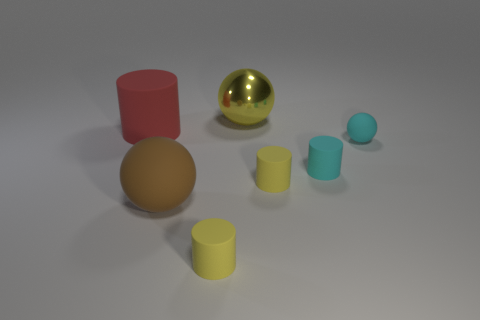There is a brown ball; what number of big brown matte spheres are behind it?
Make the answer very short. 0. Are there the same number of cyan things that are left of the brown thing and yellow matte things to the left of the yellow shiny thing?
Provide a succinct answer. No. There is a yellow rubber thing that is to the right of the metal object; is it the same shape as the red object?
Your response must be concise. Yes. Are there any other things that have the same material as the large red cylinder?
Offer a very short reply. Yes. There is a red matte thing; does it have the same size as the yellow thing on the right side of the yellow shiny ball?
Your answer should be compact. No. What number of other objects are there of the same color as the small ball?
Provide a succinct answer. 1. There is a large cylinder; are there any large red matte cylinders in front of it?
Keep it short and to the point. No. What number of things are big matte objects or rubber things that are behind the big rubber ball?
Offer a very short reply. 5. There is a yellow thing to the right of the big yellow metal ball; are there any rubber spheres that are in front of it?
Offer a very short reply. Yes. What shape is the big thing to the right of the tiny rubber thing to the left of the yellow object behind the tiny sphere?
Your answer should be compact. Sphere. 